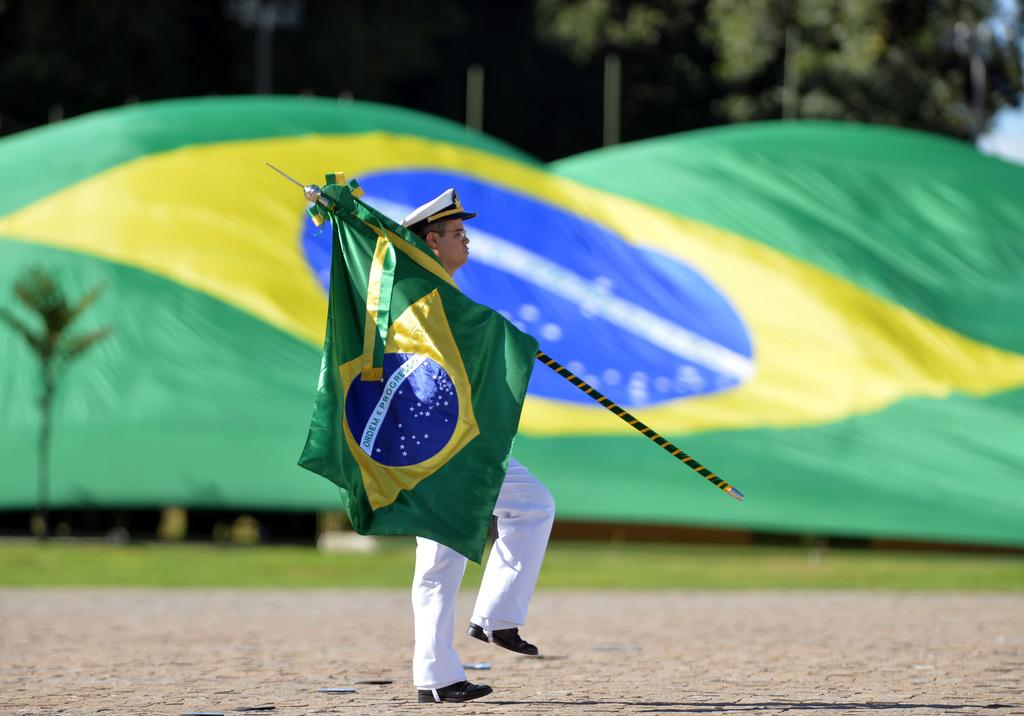What is the man in the image doing? The man in the image is walking on the road. What is the man holding in the image? The man is holding a flag with a pole. What type of vegetation can be seen in the image? A: There are trees visible in the image. What is the surface like in the image? There is grass on the surface in the image. How big is the flag in the image? There is a big flag in the image. What objects can be seen on the surface in the image? There are objects on the surface in the image. How many times does the man laugh in the image? The image does not show the man laughing, so it cannot be determined how many times he laughs. 